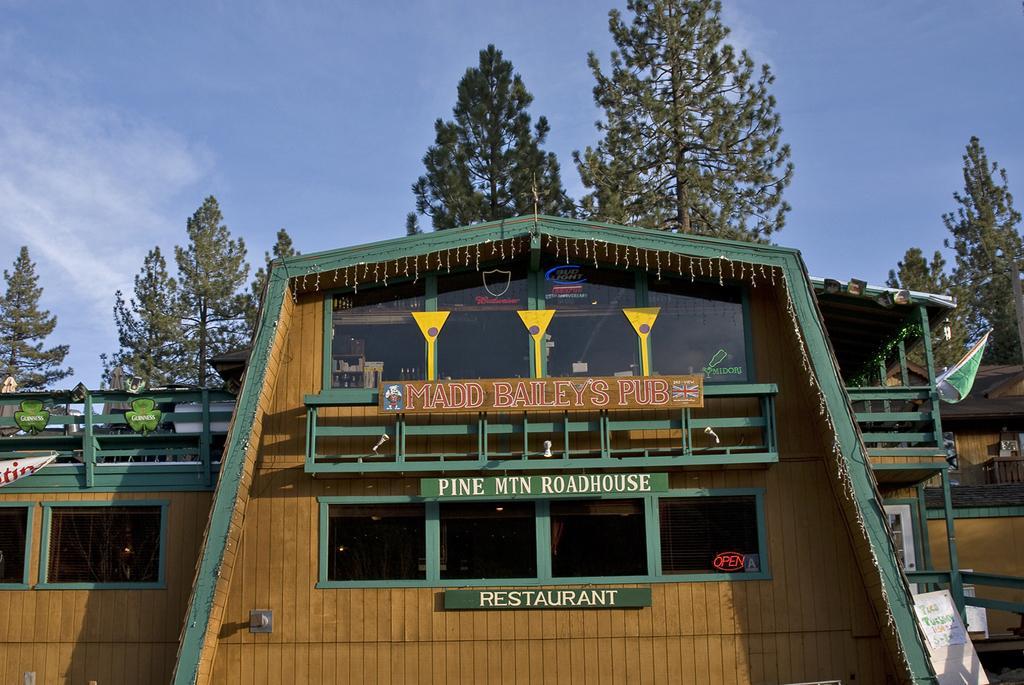Can you describe this image briefly? This image consists of a restaurant. The walls are made up of wood. In the front, there are name boards. In the background, there are trees. At the top, there are clouds in the sky. 